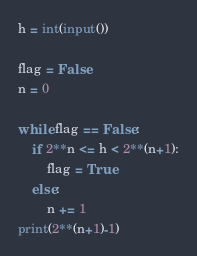<code> <loc_0><loc_0><loc_500><loc_500><_Python_>h = int(input())

flag = False
n = 0

while flag == False:
    if 2**n <= h < 2**(n+1):
        flag = True
    else:
        n += 1
print(2**(n+1)-1)</code> 